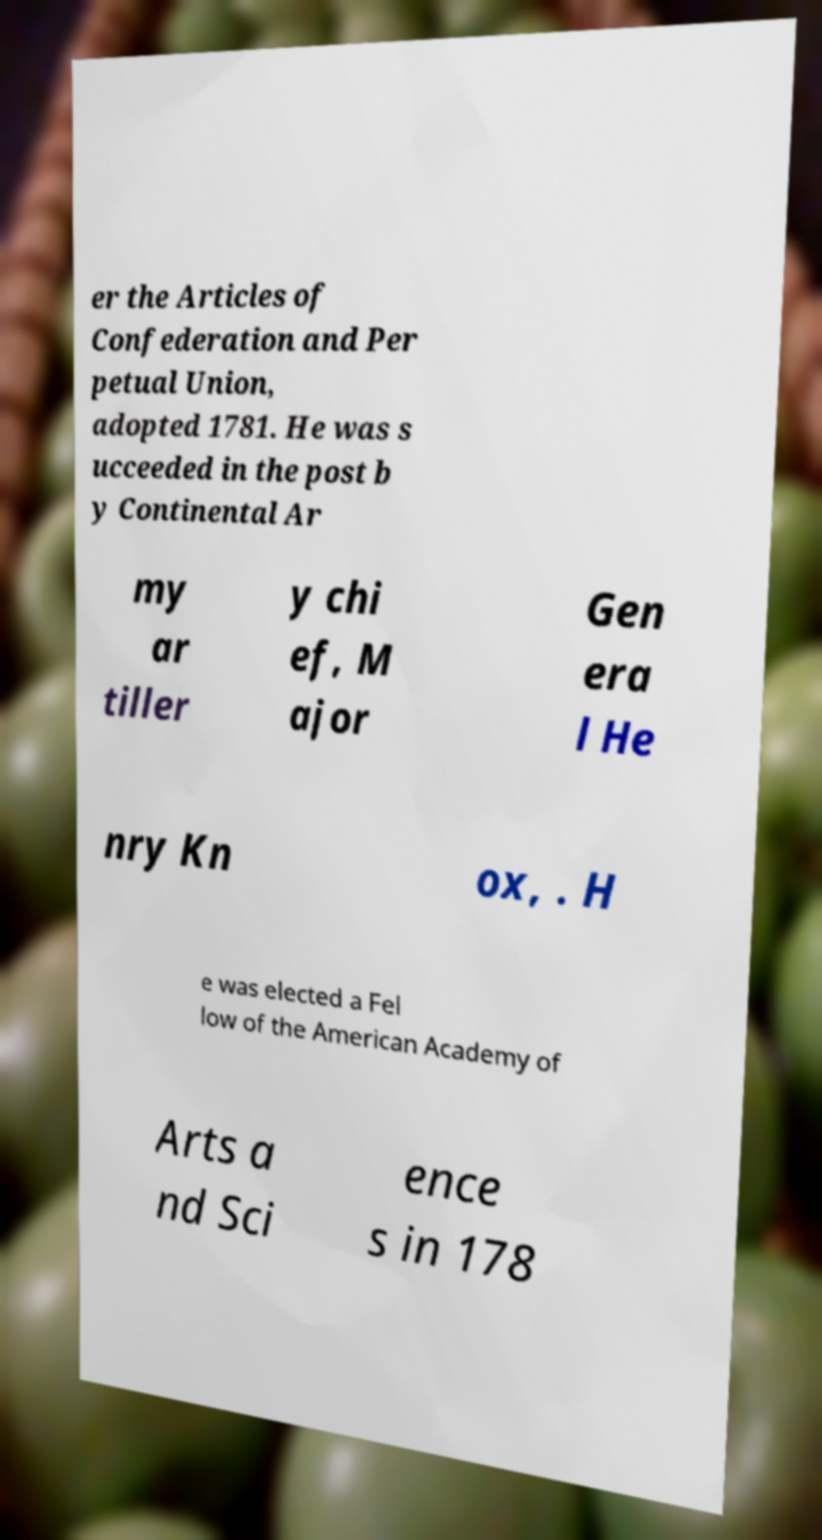What messages or text are displayed in this image? I need them in a readable, typed format. er the Articles of Confederation and Per petual Union, adopted 1781. He was s ucceeded in the post b y Continental Ar my ar tiller y chi ef, M ajor Gen era l He nry Kn ox, . H e was elected a Fel low of the American Academy of Arts a nd Sci ence s in 178 